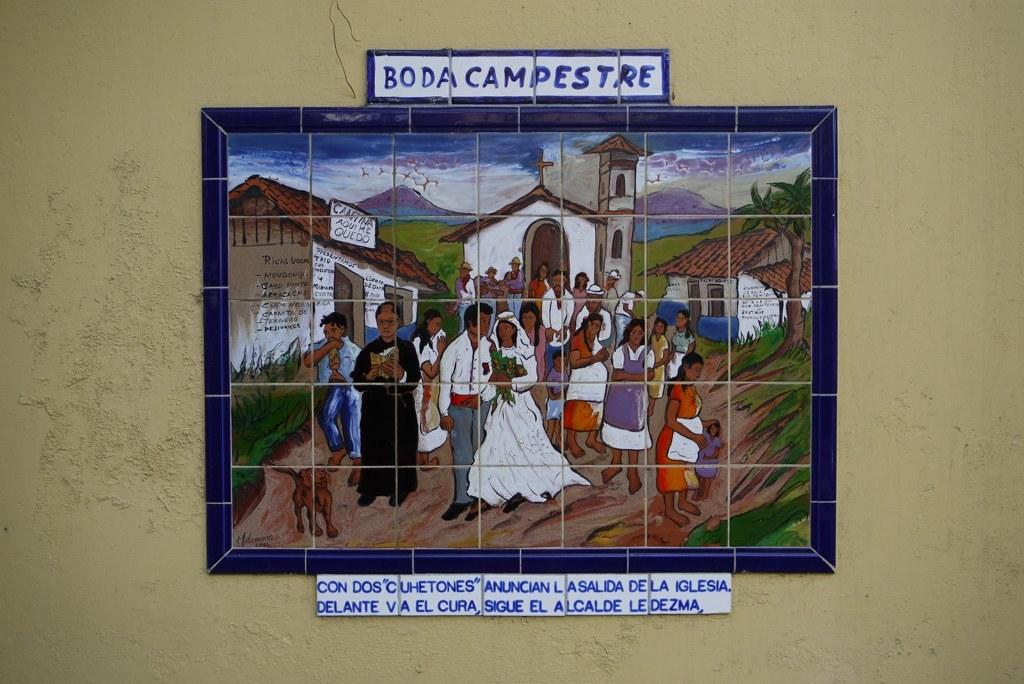<image>
Provide a brief description of the given image. A mosaic of people at a wedding is on a wall and says Boda Campestre. 